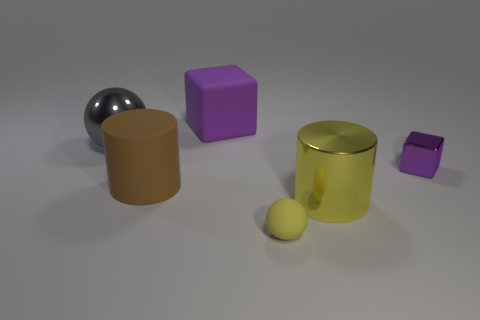The yellow object that is behind the small rubber object has what shape?
Offer a terse response. Cylinder. The big ball is what color?
Your answer should be compact. Gray. What shape is the large yellow object that is made of the same material as the big ball?
Your response must be concise. Cylinder. Does the shiny object that is to the left of the brown matte object have the same size as the large purple block?
Make the answer very short. Yes. What number of objects are big metallic objects behind the tiny metal block or cubes that are in front of the large gray ball?
Provide a succinct answer. 2. Do the cube to the left of the large metal cylinder and the small rubber sphere have the same color?
Provide a short and direct response. No. How many matte things are either big things or brown cylinders?
Keep it short and to the point. 2. What is the shape of the big purple rubber object?
Make the answer very short. Cube. Is there any other thing that is made of the same material as the brown object?
Provide a short and direct response. Yes. Does the gray thing have the same material as the yellow ball?
Your answer should be compact. No. 